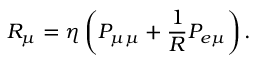<formula> <loc_0><loc_0><loc_500><loc_500>R _ { \mu } = \eta \left ( P _ { \mu \mu } + \frac { 1 } { R } P _ { e \mu } \right ) .</formula> 